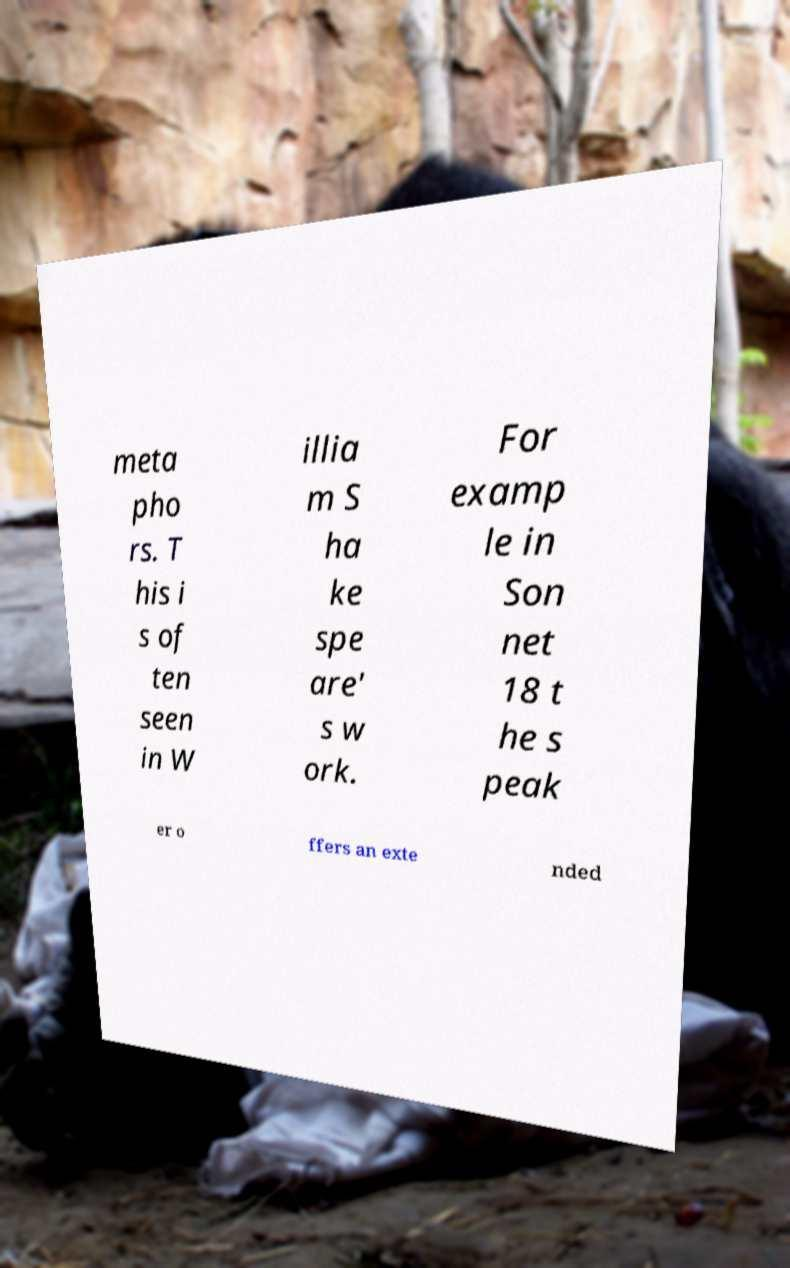Can you read and provide the text displayed in the image?This photo seems to have some interesting text. Can you extract and type it out for me? meta pho rs. T his i s of ten seen in W illia m S ha ke spe are' s w ork. For examp le in Son net 18 t he s peak er o ffers an exte nded 